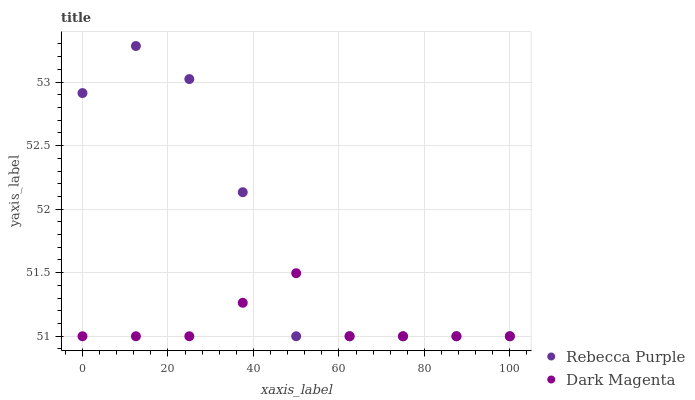Does Dark Magenta have the minimum area under the curve?
Answer yes or no. Yes. Does Rebecca Purple have the maximum area under the curve?
Answer yes or no. Yes. Does Dark Magenta have the maximum area under the curve?
Answer yes or no. No. Is Dark Magenta the smoothest?
Answer yes or no. Yes. Is Rebecca Purple the roughest?
Answer yes or no. Yes. Is Dark Magenta the roughest?
Answer yes or no. No. Does Rebecca Purple have the lowest value?
Answer yes or no. Yes. Does Rebecca Purple have the highest value?
Answer yes or no. Yes. Does Dark Magenta have the highest value?
Answer yes or no. No. Does Dark Magenta intersect Rebecca Purple?
Answer yes or no. Yes. Is Dark Magenta less than Rebecca Purple?
Answer yes or no. No. Is Dark Magenta greater than Rebecca Purple?
Answer yes or no. No. 